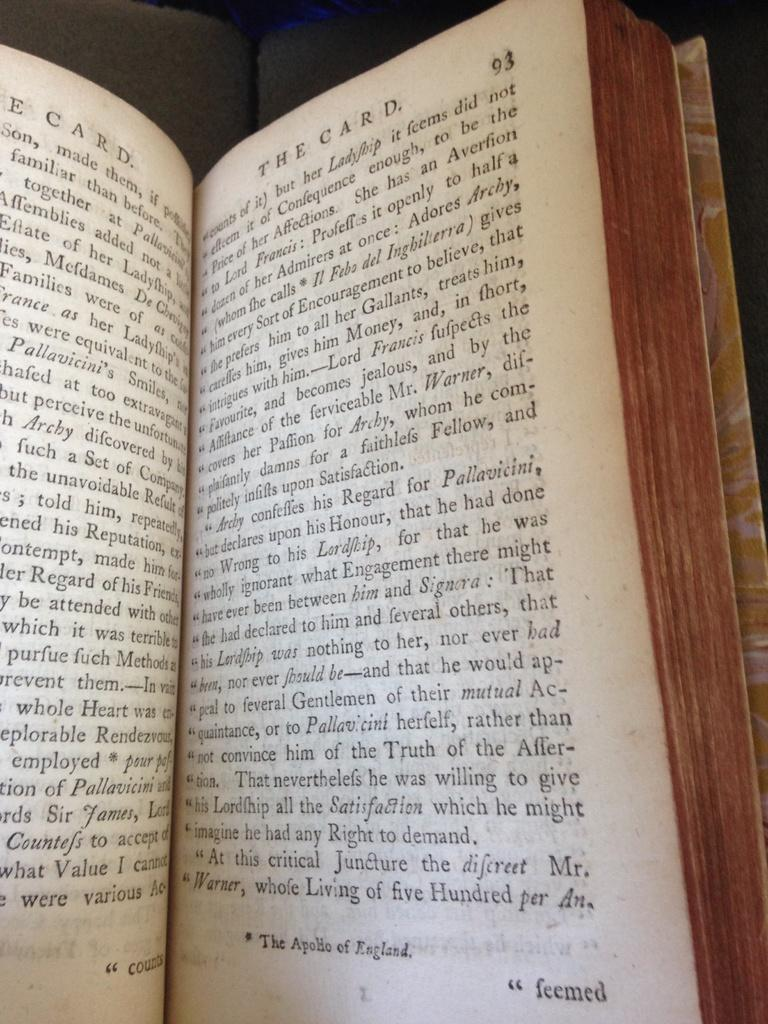Provide a one-sentence caption for the provided image. A book called "The Card" is open to page 93. 